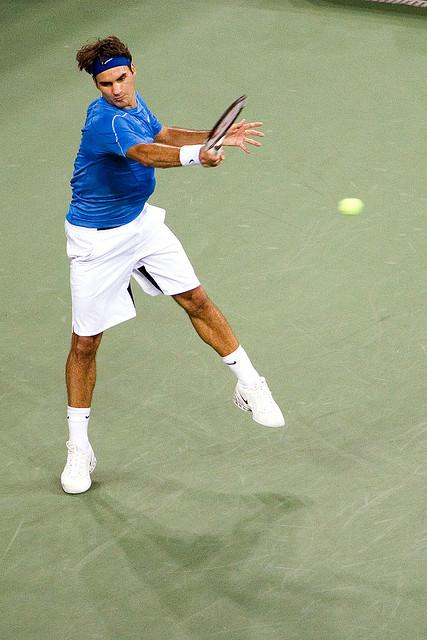What did this tennis player just do?

Choices:
A) returned ball
B) lost
C) quit
D) served returned ball 